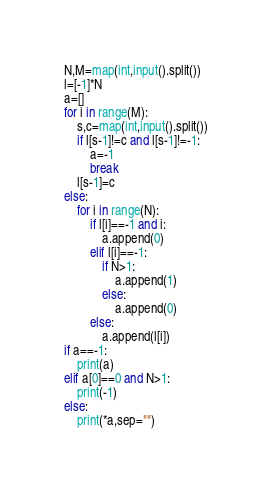Convert code to text. <code><loc_0><loc_0><loc_500><loc_500><_Python_>N,M=map(int,input().split())
l=[-1]*N
a=[]
for i in range(M):
    s,c=map(int,input().split())
    if l[s-1]!=c and l[s-1]!=-1:
        a=-1
        break
    l[s-1]=c
else:
    for i in range(N):
        if l[i]==-1 and i:
            a.append(0)
        elif l[i]==-1:
            if N>1:
                a.append(1)
            else:
                a.append(0)
        else:
            a.append(l[i])
if a==-1:
    print(a)
elif a[0]==0 and N>1:
    print(-1)
else:
    print(*a,sep="")     </code> 